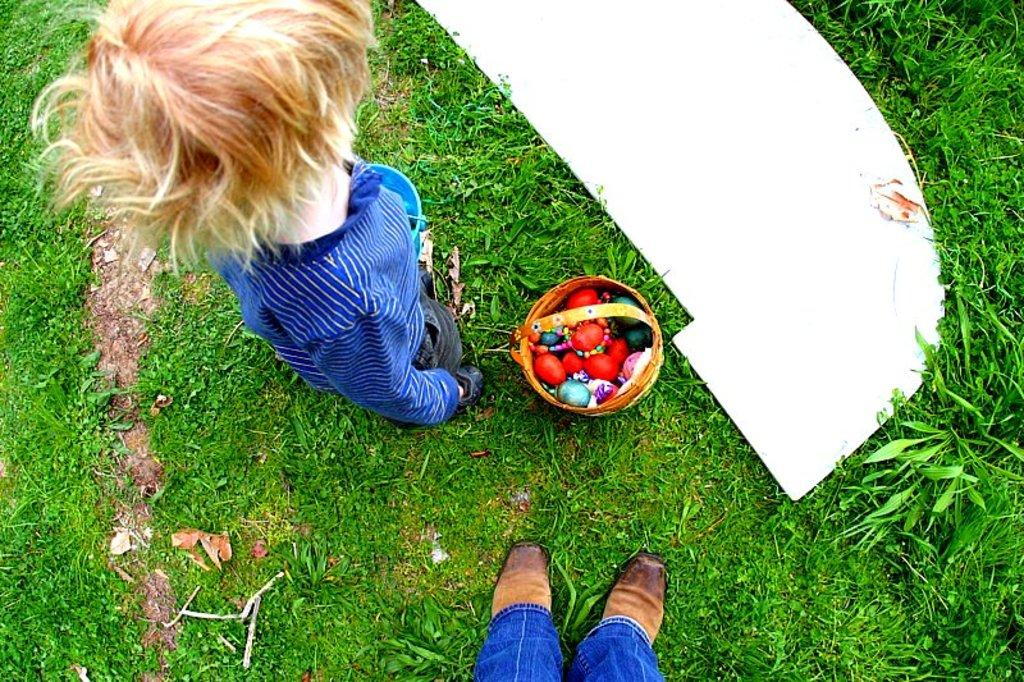Who or what is present in the image? There is a person in the image. What object can be seen near the person? There is a basket in the image. What items are visible in the image that might be related to clothing? There are shoes and clothes in the image. What type of surface is visible in the image? There are objects on the grass in the image. What type of stocking is the person wearing in the image? There is no mention of stockings in the image, so it cannot be determined if the person is wearing any. 